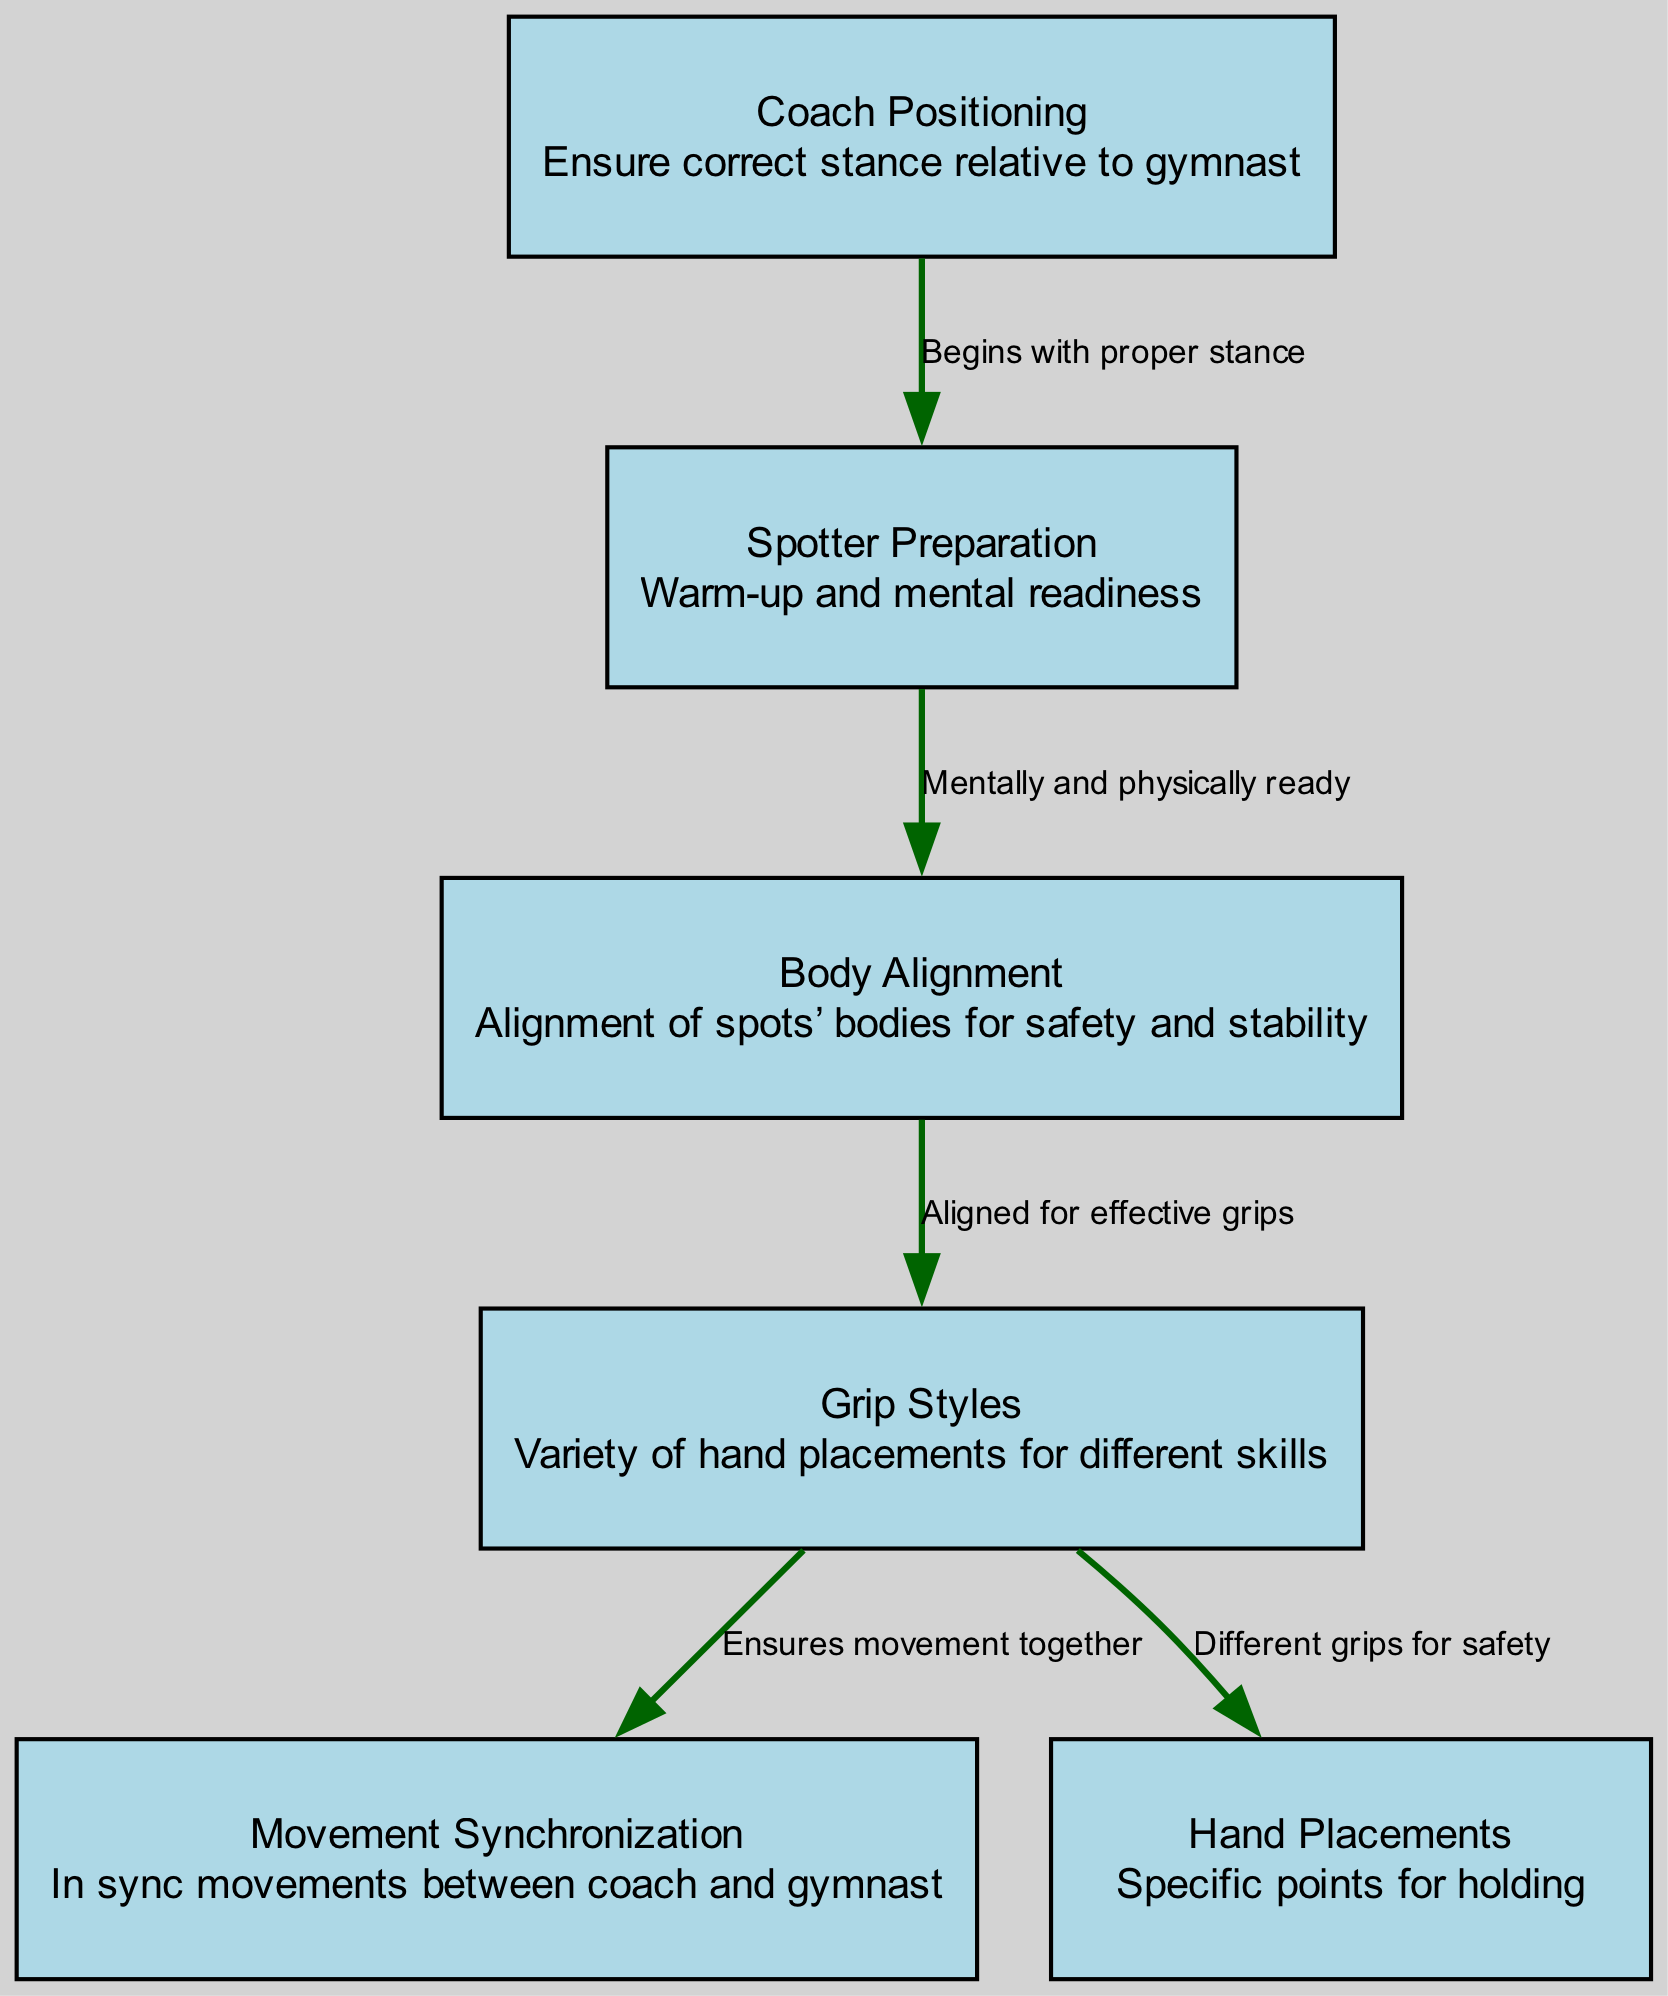What is the total number of nodes in the diagram? The diagram lists six distinct nodes which include Coach Positioning, Grip Styles, Body Alignment, Spotter Preparation, Movement Synchronization, and Hand Placements. Counting these gives a total of six nodes.
Answer: 6 What is the relationship between Spotter Preparation and Body Alignment? The edge connecting Spotter Preparation to Body Alignment indicates that being mentally and physically ready leads to proper Body Alignment. This implies a direct relationship that prepares the spotter for alignment.
Answer: Mentally and physically ready What does the Grip Styles node connect to? The Grip Styles node connects to two nodes: Hand Placements and Movement Synchronization. Each connection indicates that grip is essential for both safe hand placement and synchronized movements between the coach and gymnast.
Answer: Hand Placements, Movement Synchronization How many edges are there in the diagram? The diagram includes five directed edges that represent the relationships between the nodes: four from the nodes to their targets and one indicating an initial stance. Counting these gives a total of five edges.
Answer: 5 What begins the spotting process in the diagram? The diagram indicates that the spotting process begins with proper stance, represented by the Coach Positioning node. This node is the starting point for the entire guiding process.
Answer: Proper stance What is necessary for effective grips according to the diagram? The diagram shows that to achieve effective grips, there must be correct Body Alignment, as indicated by the direct connection from Body Alignment to Grip Styles. This emphasizes the role of alignment in grip effectiveness.
Answer: Body Alignment Which node emphasizes the importance of movement coordination? The Movement Synchronization node emphasizes the importance of coordinated movements between the coach and gymnast. This is essential for timing and safety during spotting techniques.
Answer: Movement Synchronization What prepares the spotters for their role? The Spotter Preparation node is clearly indicated as preparing spotters through warm-up and mental readiness. This step is crucial before executing any spotting techniques effectively.
Answer: Warm-up and mental readiness What connects Grip Styles to Hand Placements? The edge connecting Grip Styles to Hand Placements emphasizes that different grips provide safety, meaning that the style of grip chosen directly influences where and how hands are placed during spotting.
Answer: Different grips for safety 